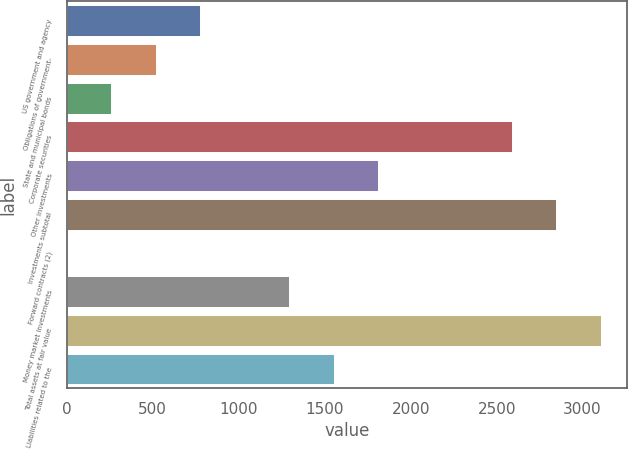<chart> <loc_0><loc_0><loc_500><loc_500><bar_chart><fcel>US government and agency<fcel>Obligations of government-<fcel>State and municipal bonds<fcel>Corporate securities<fcel>Other investments<fcel>Investments subtotal<fcel>Forward contracts (2)<fcel>Money market investments<fcel>Total assets at fair value<fcel>Liabilities related to the<nl><fcel>776.99<fcel>518.27<fcel>259.55<fcel>2588<fcel>1811.87<fcel>2846.72<fcel>0.83<fcel>1294.43<fcel>3105.44<fcel>1553.15<nl></chart> 